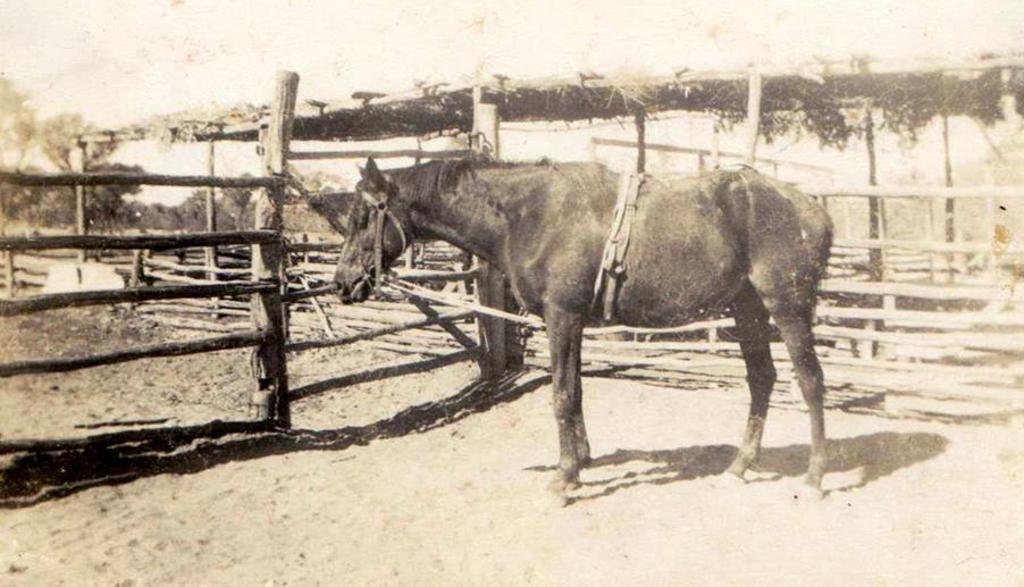In one or two sentences, can you explain what this image depicts? This image consists of a horse in black color. At the bottom, there is sand. On the left, we can see a fencing made up of wood. In the background, there is a hut. 